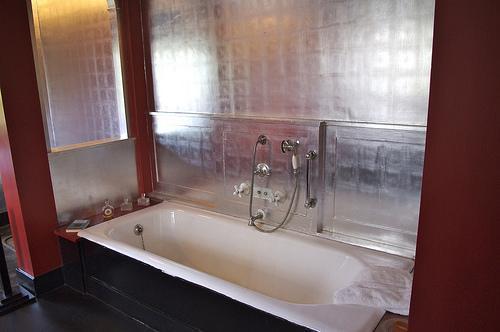How many pillars are visible?
Give a very brief answer. 3. 